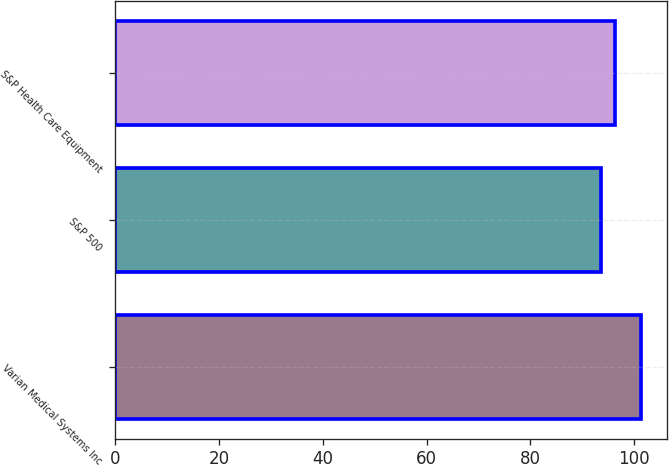Convert chart to OTSL. <chart><loc_0><loc_0><loc_500><loc_500><bar_chart><fcel>Varian Medical Systems Inc<fcel>S&P 500<fcel>S&P Health Care Equipment<nl><fcel>101.27<fcel>93.7<fcel>96.34<nl></chart> 